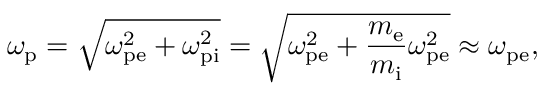Convert formula to latex. <formula><loc_0><loc_0><loc_500><loc_500>\omega _ { p } = \sqrt { \omega _ { p e } ^ { 2 } + \omega _ { p i } ^ { 2 } } = \sqrt { \omega _ { p e } ^ { 2 } + \frac { m _ { e } } { m _ { i } } \omega _ { p e } ^ { 2 } } \approx \omega _ { p e } ,</formula> 